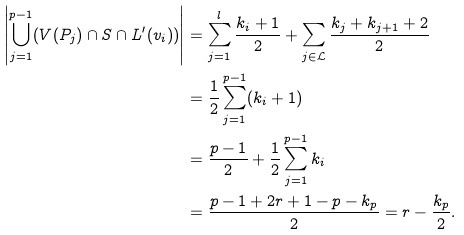Convert formula to latex. <formula><loc_0><loc_0><loc_500><loc_500>\left | \bigcup _ { j = 1 } ^ { p - 1 } ( V ( P _ { j } ) \cap S \cap L ^ { \prime } ( v _ { i } ) ) \right | & = \sum _ { j = 1 } ^ { l } \frac { k _ { i } + 1 } { 2 } + \sum _ { j \in \mathcal { L } } \frac { k _ { j } + k _ { j + 1 } + 2 } { 2 } \\ & = \frac { 1 } { 2 } \sum _ { j = 1 } ^ { p - 1 } ( k _ { i } + 1 ) \\ & = \frac { p - 1 } { 2 } + \frac { 1 } { 2 } \sum _ { j = 1 } ^ { p - 1 } k _ { i } \\ & = \frac { p - 1 + 2 r + 1 - p - k _ { p } } { 2 } = r - \frac { k _ { p } } { 2 } .</formula> 